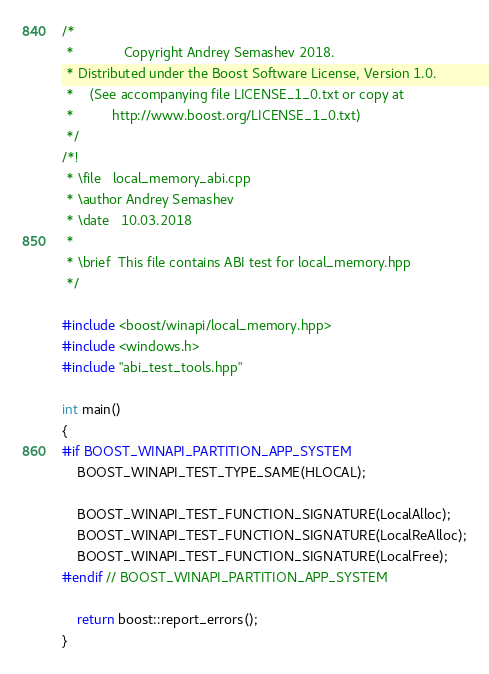<code> <loc_0><loc_0><loc_500><loc_500><_C++_>/*
 *             Copyright Andrey Semashev 2018.
 * Distributed under the Boost Software License, Version 1.0.
 *    (See accompanying file LICENSE_1_0.txt or copy at
 *          http://www.boost.org/LICENSE_1_0.txt)
 */
/*!
 * \file   local_memory_abi.cpp
 * \author Andrey Semashev
 * \date   10.03.2018
 *
 * \brief  This file contains ABI test for local_memory.hpp
 */

#include <boost/winapi/local_memory.hpp>
#include <windows.h>
#include "abi_test_tools.hpp"

int main()
{
#if BOOST_WINAPI_PARTITION_APP_SYSTEM
    BOOST_WINAPI_TEST_TYPE_SAME(HLOCAL);

    BOOST_WINAPI_TEST_FUNCTION_SIGNATURE(LocalAlloc);
    BOOST_WINAPI_TEST_FUNCTION_SIGNATURE(LocalReAlloc);
    BOOST_WINAPI_TEST_FUNCTION_SIGNATURE(LocalFree);
#endif // BOOST_WINAPI_PARTITION_APP_SYSTEM

    return boost::report_errors();
}
</code> 